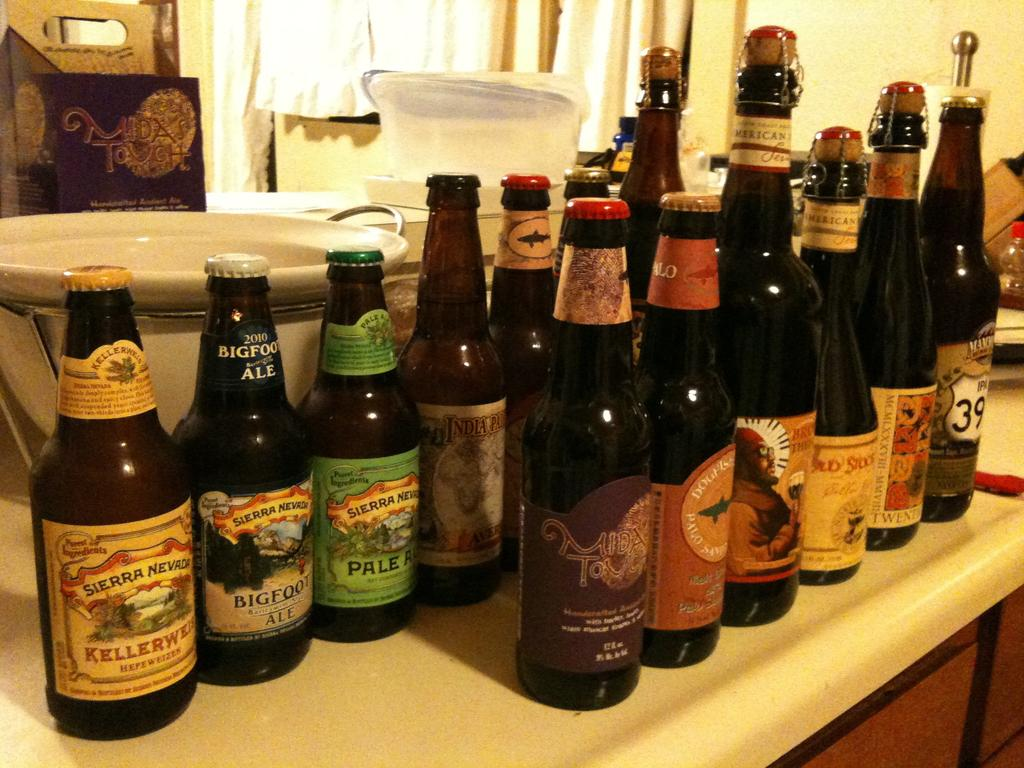<image>
Give a short and clear explanation of the subsequent image. A bottle of big foot ale is on a counter with other bottles. 